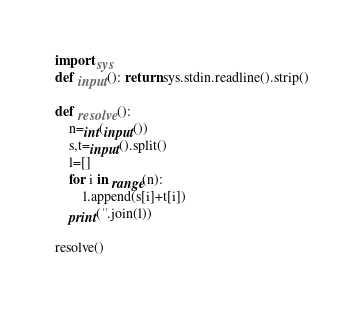<code> <loc_0><loc_0><loc_500><loc_500><_Python_>import sys
def input(): return sys.stdin.readline().strip()

def resolve():
    n=int(input())
    s,t=input().split()
    l=[]
    for i in range(n):
        l.append(s[i]+t[i])
    print(''.join(l))

resolve()</code> 